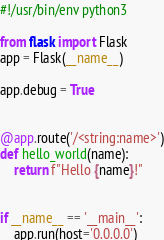Convert code to text. <code><loc_0><loc_0><loc_500><loc_500><_Python_>#!/usr/bin/env python3

from flask import Flask
app = Flask(__name__)

app.debug = True


@app.route('/<string:name>')
def hello_world(name):
    return f"Hello {name}!"


if __name__ == '__main__':
    app.run(host='0.0.0.0')
</code> 